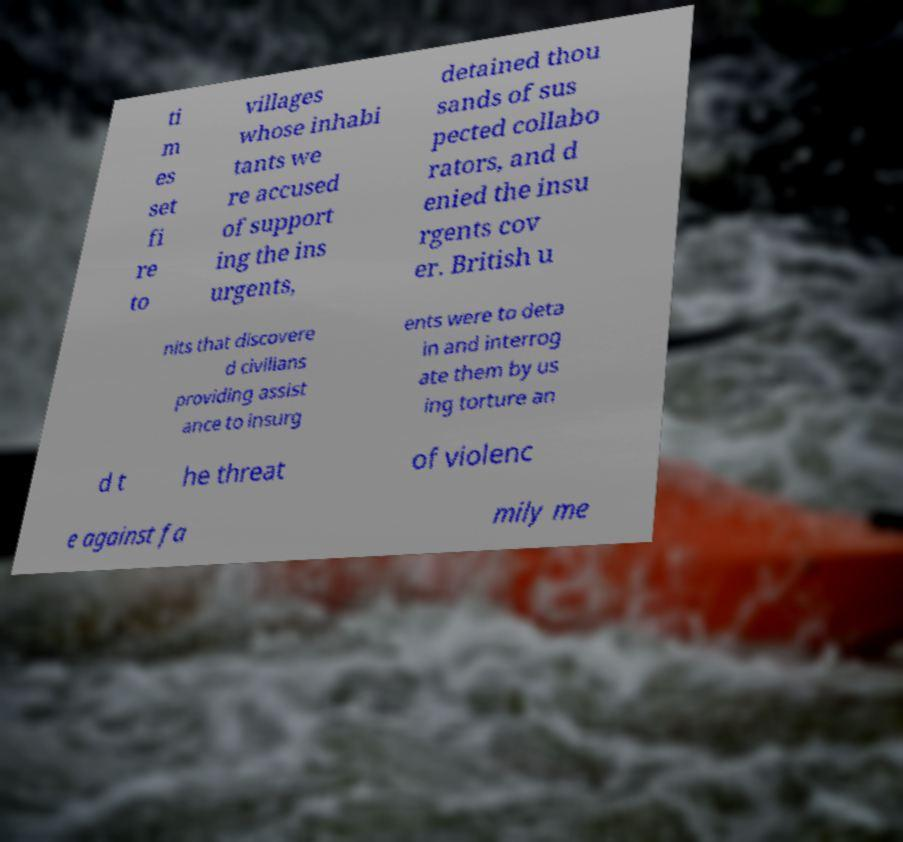Please identify and transcribe the text found in this image. ti m es set fi re to villages whose inhabi tants we re accused of support ing the ins urgents, detained thou sands of sus pected collabo rators, and d enied the insu rgents cov er. British u nits that discovere d civilians providing assist ance to insurg ents were to deta in and interrog ate them by us ing torture an d t he threat of violenc e against fa mily me 